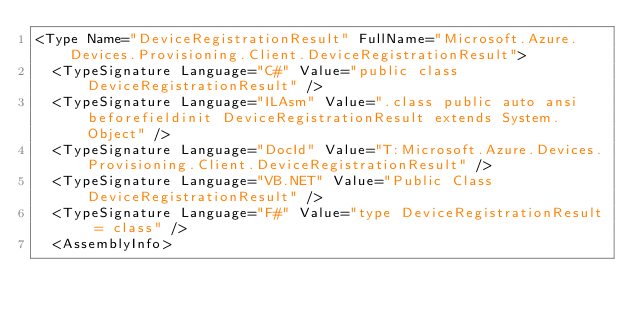Convert code to text. <code><loc_0><loc_0><loc_500><loc_500><_XML_><Type Name="DeviceRegistrationResult" FullName="Microsoft.Azure.Devices.Provisioning.Client.DeviceRegistrationResult">
  <TypeSignature Language="C#" Value="public class DeviceRegistrationResult" />
  <TypeSignature Language="ILAsm" Value=".class public auto ansi beforefieldinit DeviceRegistrationResult extends System.Object" />
  <TypeSignature Language="DocId" Value="T:Microsoft.Azure.Devices.Provisioning.Client.DeviceRegistrationResult" />
  <TypeSignature Language="VB.NET" Value="Public Class DeviceRegistrationResult" />
  <TypeSignature Language="F#" Value="type DeviceRegistrationResult = class" />
  <AssemblyInfo></code> 